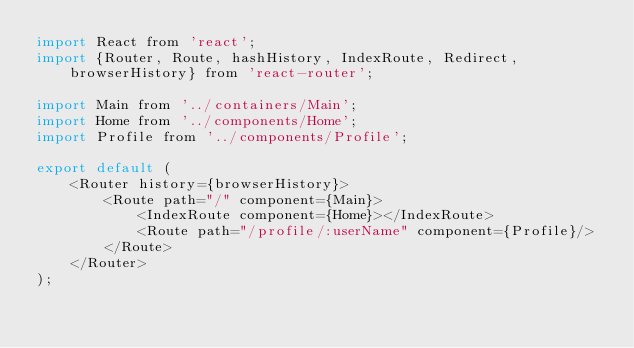<code> <loc_0><loc_0><loc_500><loc_500><_JavaScript_>import React from 'react';
import {Router, Route, hashHistory, IndexRoute, Redirect, browserHistory} from 'react-router';

import Main from '../containers/Main';
import Home from '../components/Home';
import Profile from '../components/Profile';

export default (
    <Router history={browserHistory}>
        <Route path="/" component={Main}>
            <IndexRoute component={Home}></IndexRoute>
            <Route path="/profile/:userName" component={Profile}/>
        </Route>
    </Router>
);</code> 